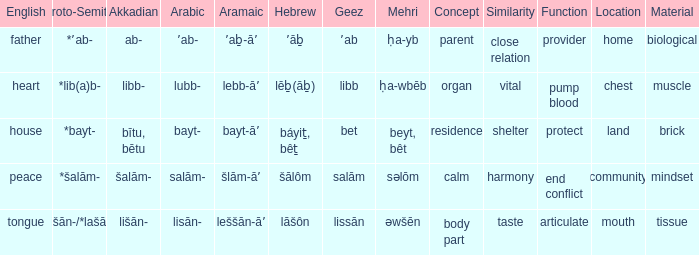If the proto-semitic is *bayt-, what are the geez equivalents? Bet. 